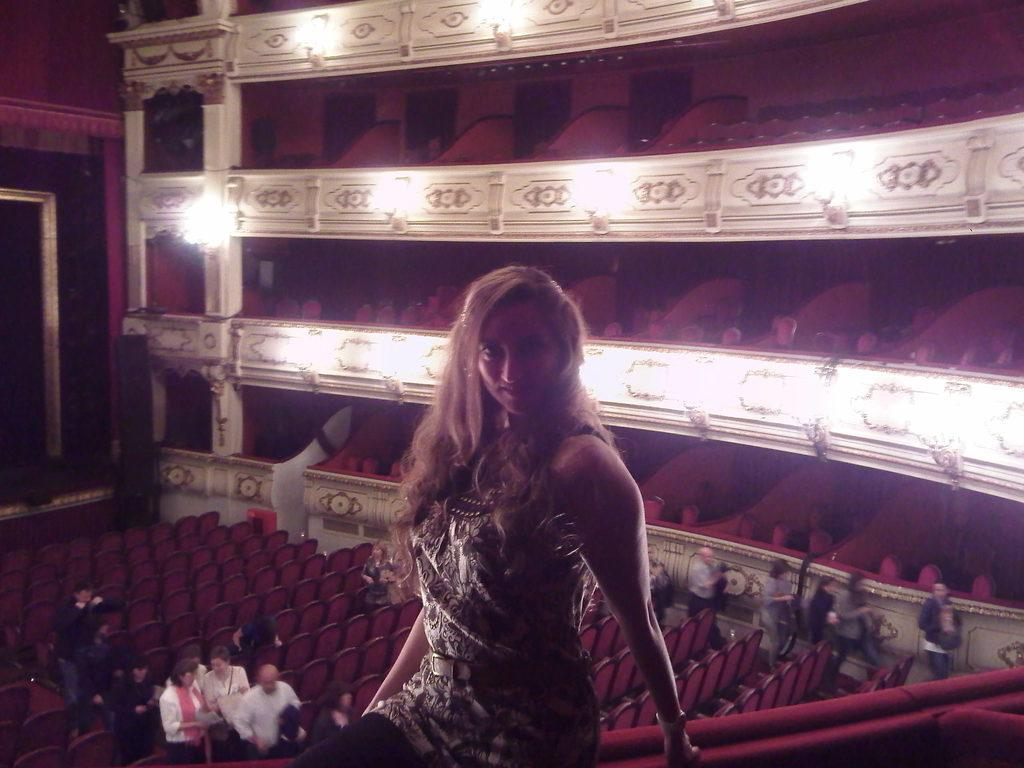What is the woman in the image doing? The woman is sitting in the image. Can you describe the other people in the image? There is a group of people in the image. What type of furniture is present in the image? There are chairs in the image. What architectural features can be seen in the image? There are pillars in the image. What type of lighting is present in the image? There are lights in the image. What other objects can be seen in the image? There are some other objects in the image. What type of loaf is being used as a table in the image? There is no loaf present in the image, and no loaf is being used as a table. 